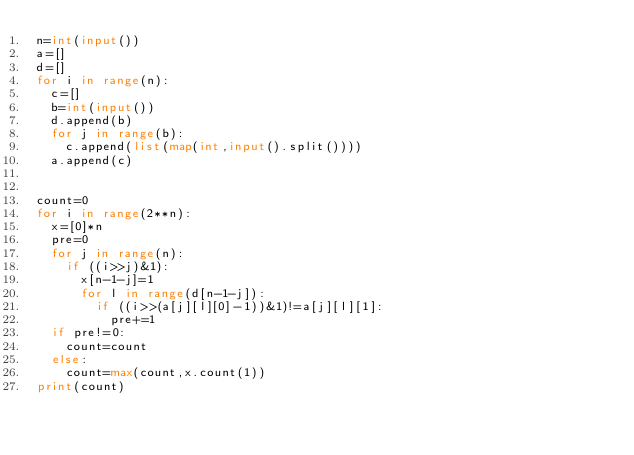Convert code to text. <code><loc_0><loc_0><loc_500><loc_500><_Python_>n=int(input())
a=[]
d=[]
for i in range(n):
  c=[]
  b=int(input())
  d.append(b)
  for j in range(b):
    c.append(list(map(int,input().split())))
  a.append(c)


count=0
for i in range(2**n):
  x=[0]*n
  pre=0
  for j in range(n):
    if ((i>>j)&1):
      x[n-1-j]=1 
      for l in range(d[n-1-j]):
        if ((i>>(a[j][l][0]-1))&1)!=a[j][l][1]:
          pre+=1
  if pre!=0:
    count=count
  else:
    count=max(count,x.count(1))
print(count)</code> 